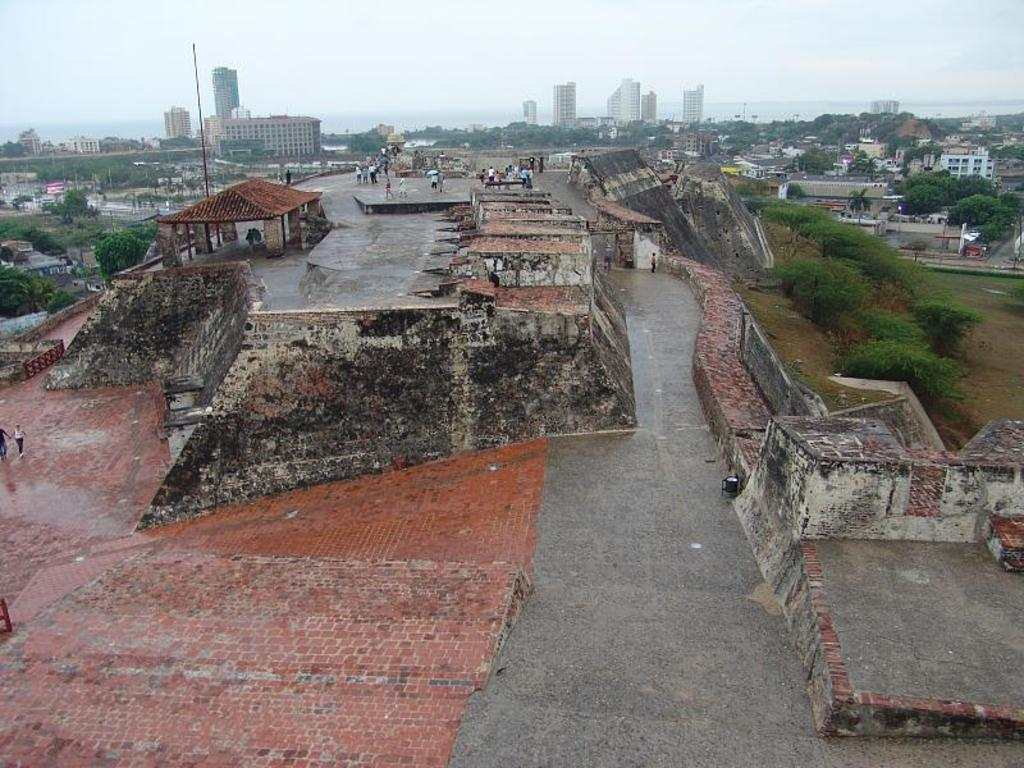What is the main subject of the image? The main subject of the image is houses on a hill path. Are there any people present in the image? Yes, there are people near the houses on the hill path. What can be seen in the background of the image? In the background of the image, there are houses, buildings, tower buildings, and the sky. What type of elbow can be seen on the page in the image? There is no page or elbow present in the image. 